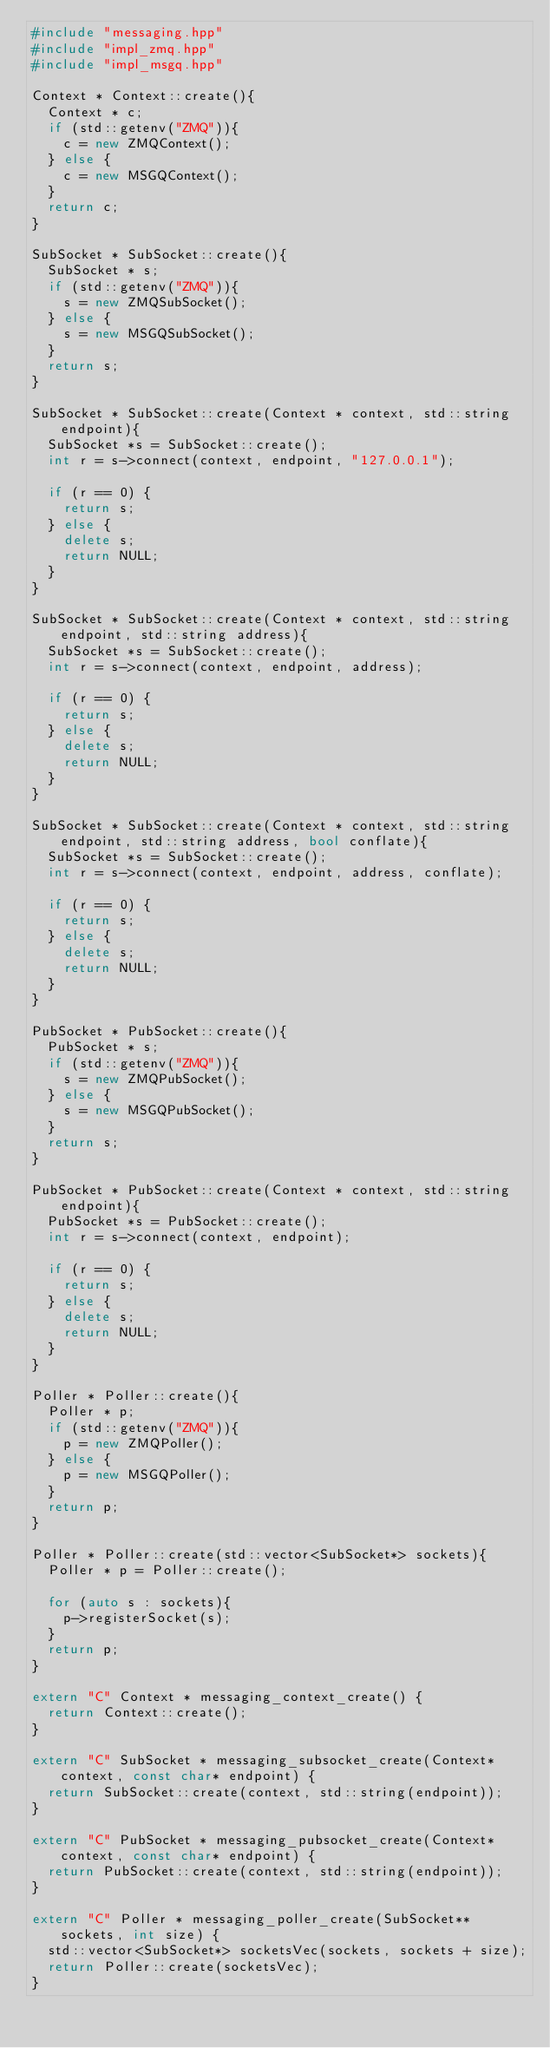<code> <loc_0><loc_0><loc_500><loc_500><_C++_>#include "messaging.hpp"
#include "impl_zmq.hpp"
#include "impl_msgq.hpp"

Context * Context::create(){
  Context * c;
  if (std::getenv("ZMQ")){
    c = new ZMQContext();
  } else {
    c = new MSGQContext();
  }
  return c;
}

SubSocket * SubSocket::create(){
  SubSocket * s;
  if (std::getenv("ZMQ")){
    s = new ZMQSubSocket();
  } else {
    s = new MSGQSubSocket();
  }
  return s;
}

SubSocket * SubSocket::create(Context * context, std::string endpoint){
  SubSocket *s = SubSocket::create();
  int r = s->connect(context, endpoint, "127.0.0.1");

  if (r == 0) {
    return s;
  } else {
    delete s;
    return NULL;
  }
}

SubSocket * SubSocket::create(Context * context, std::string endpoint, std::string address){
  SubSocket *s = SubSocket::create();
  int r = s->connect(context, endpoint, address);

  if (r == 0) {
    return s;
  } else {
    delete s;
    return NULL;
  }
}

SubSocket * SubSocket::create(Context * context, std::string endpoint, std::string address, bool conflate){
  SubSocket *s = SubSocket::create();
  int r = s->connect(context, endpoint, address, conflate);

  if (r == 0) {
    return s;
  } else {
    delete s;
    return NULL;
  }
}

PubSocket * PubSocket::create(){
  PubSocket * s;
  if (std::getenv("ZMQ")){
    s = new ZMQPubSocket();
  } else {
    s = new MSGQPubSocket();
  }
  return s;
}

PubSocket * PubSocket::create(Context * context, std::string endpoint){
  PubSocket *s = PubSocket::create();
  int r = s->connect(context, endpoint);

  if (r == 0) {
    return s;
  } else {
    delete s;
    return NULL;
  }
}

Poller * Poller::create(){
  Poller * p;
  if (std::getenv("ZMQ")){
    p = new ZMQPoller();
  } else {
    p = new MSGQPoller();
  }
  return p;
}

Poller * Poller::create(std::vector<SubSocket*> sockets){
  Poller * p = Poller::create();

  for (auto s : sockets){
    p->registerSocket(s);
  }
  return p;
}

extern "C" Context * messaging_context_create() {
  return Context::create();
}

extern "C" SubSocket * messaging_subsocket_create(Context* context, const char* endpoint) {
  return SubSocket::create(context, std::string(endpoint));
}

extern "C" PubSocket * messaging_pubsocket_create(Context* context, const char* endpoint) {
  return PubSocket::create(context, std::string(endpoint));
}

extern "C" Poller * messaging_poller_create(SubSocket** sockets, int size) {
  std::vector<SubSocket*> socketsVec(sockets, sockets + size);
  return Poller::create(socketsVec);
}
</code> 